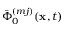Convert formula to latex. <formula><loc_0><loc_0><loc_500><loc_500>\bar { \Phi } _ { 0 } ^ { ( m j ) } ( x , t )</formula> 